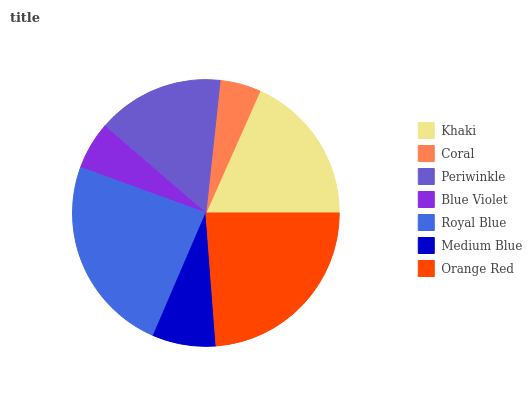Is Coral the minimum?
Answer yes or no. Yes. Is Royal Blue the maximum?
Answer yes or no. Yes. Is Periwinkle the minimum?
Answer yes or no. No. Is Periwinkle the maximum?
Answer yes or no. No. Is Periwinkle greater than Coral?
Answer yes or no. Yes. Is Coral less than Periwinkle?
Answer yes or no. Yes. Is Coral greater than Periwinkle?
Answer yes or no. No. Is Periwinkle less than Coral?
Answer yes or no. No. Is Periwinkle the high median?
Answer yes or no. Yes. Is Periwinkle the low median?
Answer yes or no. Yes. Is Coral the high median?
Answer yes or no. No. Is Orange Red the low median?
Answer yes or no. No. 